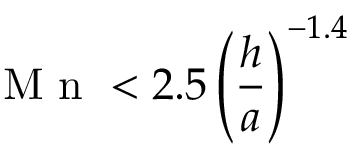<formula> <loc_0><loc_0><loc_500><loc_500>M n < 2 . 5 \left ( \frac { h } { a } \right ) ^ { - 1 . 4 }</formula> 